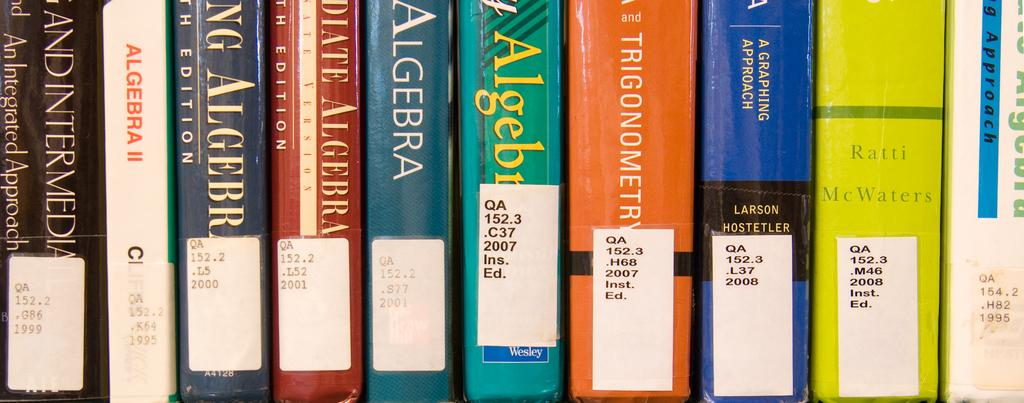<image>
Give a short and clear explanation of the subsequent image. A large selection of books which are at least mostly about algebra. 